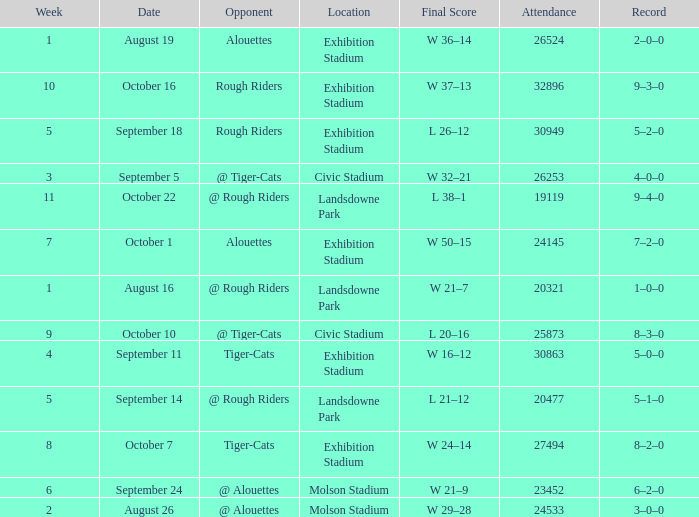How many dates for the week of 4? 1.0. 